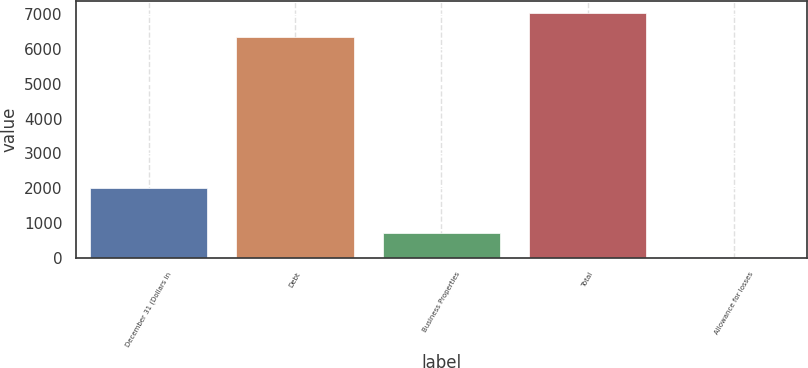Convert chart. <chart><loc_0><loc_0><loc_500><loc_500><bar_chart><fcel>December 31 (Dollars in<fcel>Debt<fcel>Business Properties<fcel>Total<fcel>Allowance for losses<nl><fcel>2011<fcel>6351<fcel>709.03<fcel>7044.33<fcel>15.7<nl></chart> 